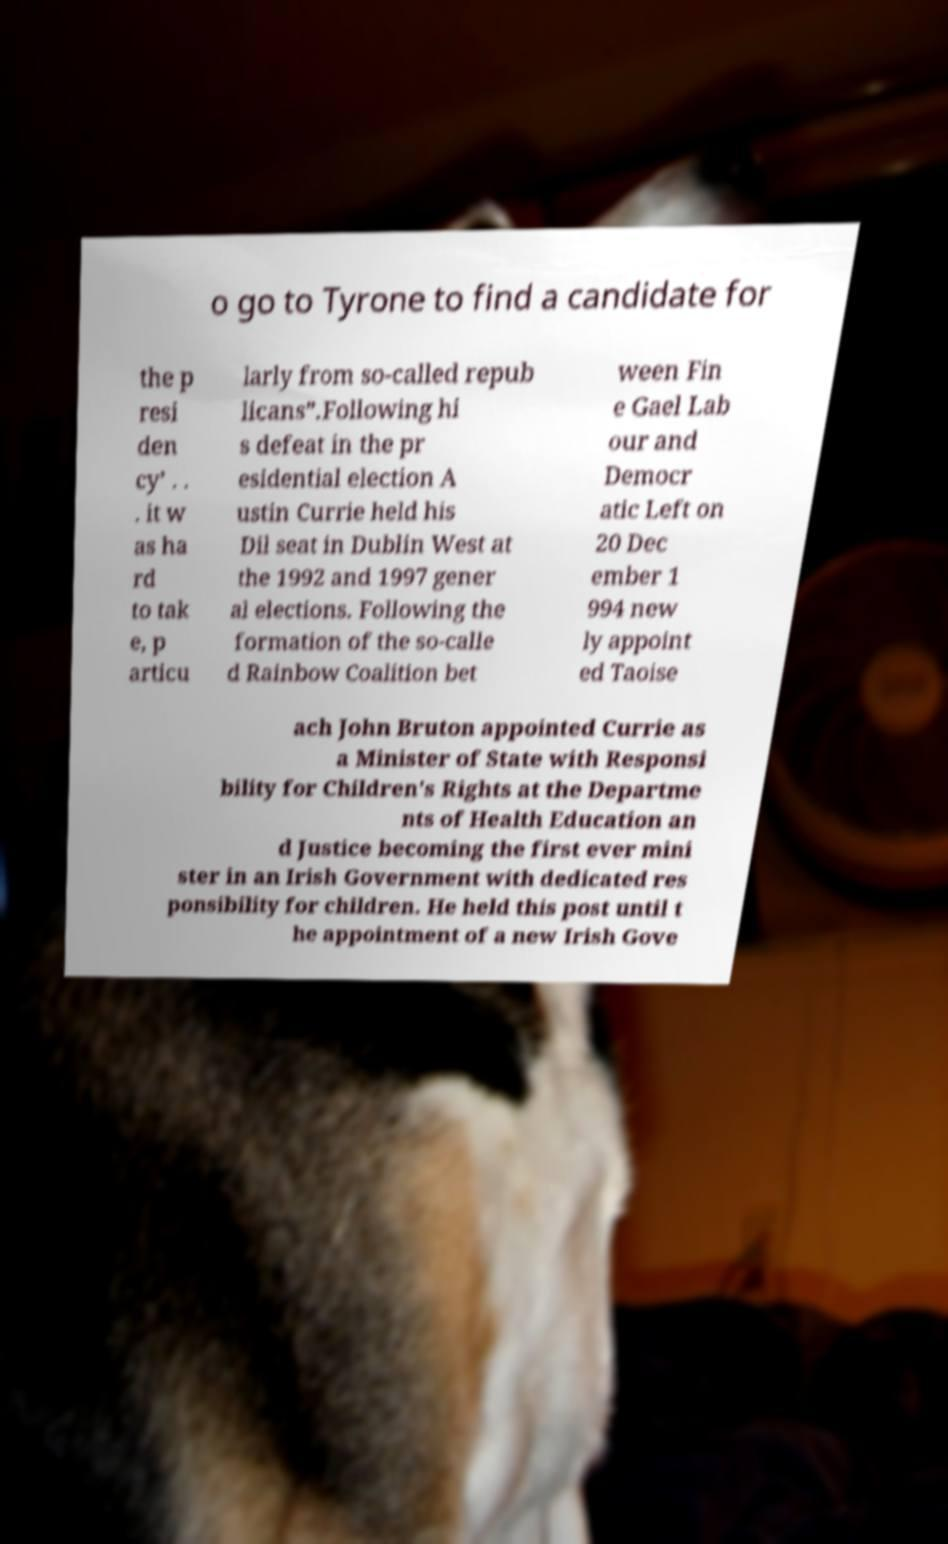For documentation purposes, I need the text within this image transcribed. Could you provide that? o go to Tyrone to find a candidate for the p resi den cy’ . . . it w as ha rd to tak e, p articu larly from so-called repub licans”.Following hi s defeat in the pr esidential election A ustin Currie held his Dil seat in Dublin West at the 1992 and 1997 gener al elections. Following the formation of the so-calle d Rainbow Coalition bet ween Fin e Gael Lab our and Democr atic Left on 20 Dec ember 1 994 new ly appoint ed Taoise ach John Bruton appointed Currie as a Minister of State with Responsi bility for Children's Rights at the Departme nts of Health Education an d Justice becoming the first ever mini ster in an Irish Government with dedicated res ponsibility for children. He held this post until t he appointment of a new Irish Gove 